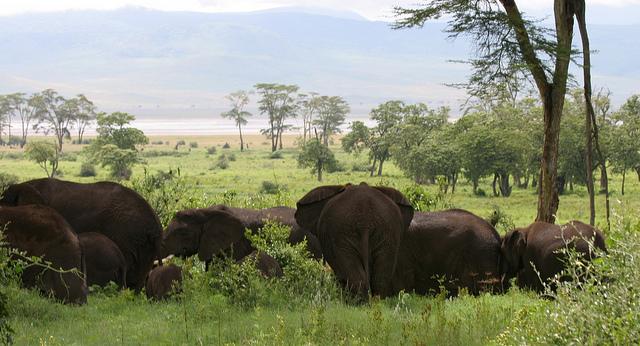What kind of animal is this?
Short answer required. Elephant. Is it day or night?
Keep it brief. Day. What animals are in the photo?
Quick response, please. Elephants. What color is the ground covering?
Be succinct. Green. 